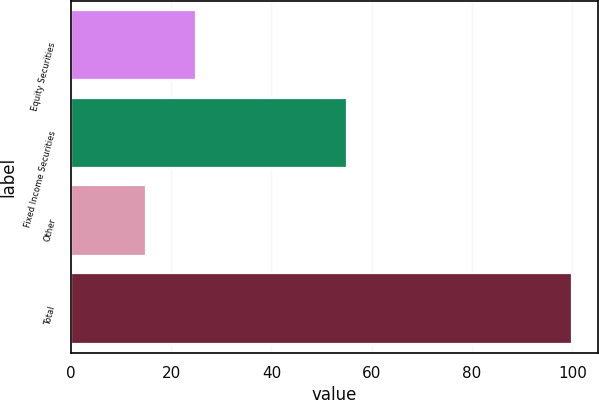<chart> <loc_0><loc_0><loc_500><loc_500><bar_chart><fcel>Equity Securities<fcel>Fixed Income Securities<fcel>Other<fcel>Total<nl><fcel>25<fcel>55<fcel>15<fcel>100<nl></chart> 